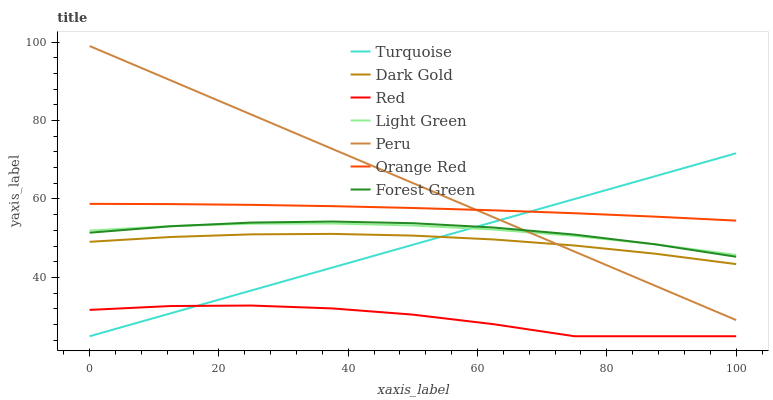Does Red have the minimum area under the curve?
Answer yes or no. Yes. Does Peru have the maximum area under the curve?
Answer yes or no. Yes. Does Light Green have the minimum area under the curve?
Answer yes or no. No. Does Light Green have the maximum area under the curve?
Answer yes or no. No. Is Turquoise the smoothest?
Answer yes or no. Yes. Is Red the roughest?
Answer yes or no. Yes. Is Light Green the smoothest?
Answer yes or no. No. Is Light Green the roughest?
Answer yes or no. No. Does Turquoise have the lowest value?
Answer yes or no. Yes. Does Light Green have the lowest value?
Answer yes or no. No. Does Peru have the highest value?
Answer yes or no. Yes. Does Light Green have the highest value?
Answer yes or no. No. Is Forest Green less than Orange Red?
Answer yes or no. Yes. Is Forest Green greater than Red?
Answer yes or no. Yes. Does Peru intersect Orange Red?
Answer yes or no. Yes. Is Peru less than Orange Red?
Answer yes or no. No. Is Peru greater than Orange Red?
Answer yes or no. No. Does Forest Green intersect Orange Red?
Answer yes or no. No. 